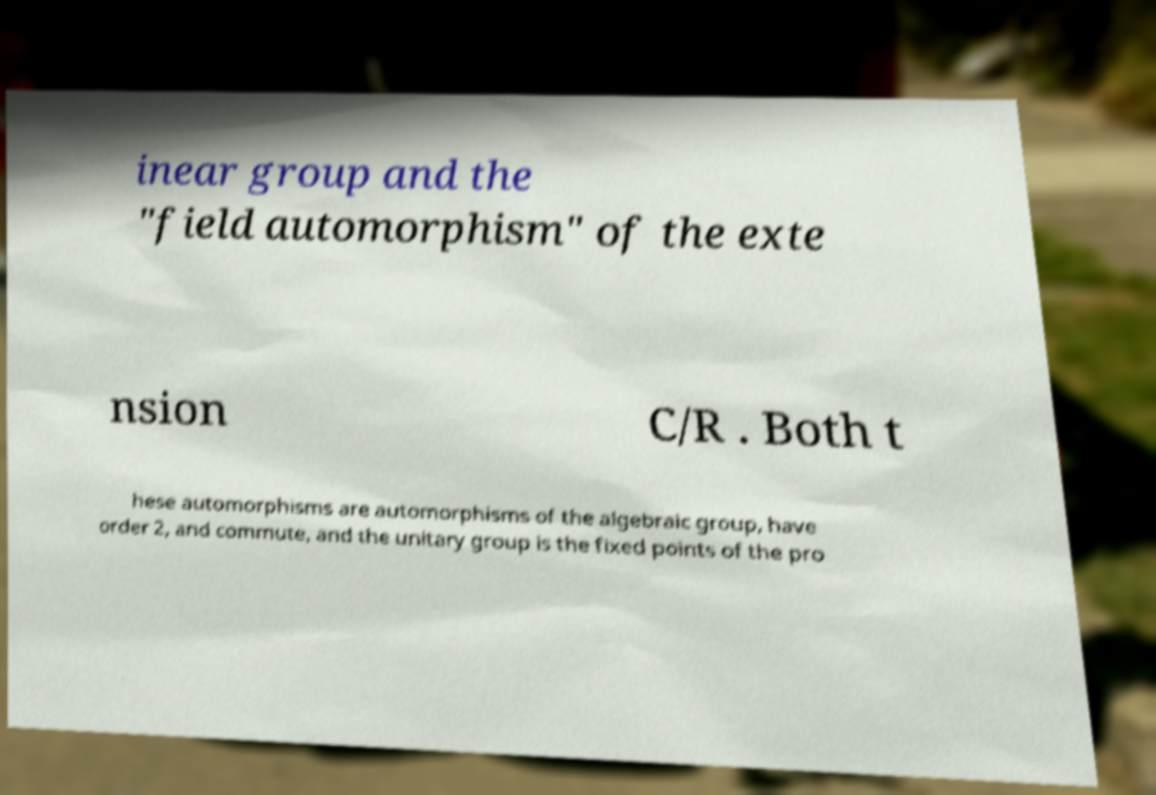What messages or text are displayed in this image? I need them in a readable, typed format. inear group and the "field automorphism" of the exte nsion C/R . Both t hese automorphisms are automorphisms of the algebraic group, have order 2, and commute, and the unitary group is the fixed points of the pro 